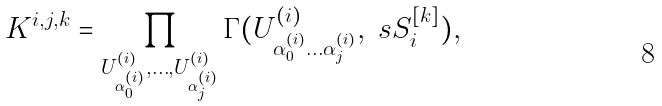Convert formula to latex. <formula><loc_0><loc_0><loc_500><loc_500>K ^ { i , j , k } = \prod _ { U ^ { ( i ) } _ { \alpha ^ { ( i ) } _ { 0 } } , \dots , U ^ { ( i ) } _ { \alpha ^ { ( i ) } _ { j } } } \Gamma ( U ^ { ( i ) } _ { \alpha ^ { ( i ) } _ { 0 } \dots \alpha ^ { ( i ) } _ { j } } , \ s S _ { i } ^ { [ k ] } ) ,</formula> 